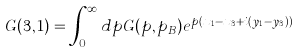Convert formula to latex. <formula><loc_0><loc_0><loc_500><loc_500>G ( 3 , 1 ) = \int _ { 0 } ^ { \infty } d p G ( p , p _ { B } ) e ^ { p ( x _ { 1 } - x _ { 3 } + i ( y _ { 1 } - y _ { 3 } ) ) }</formula> 